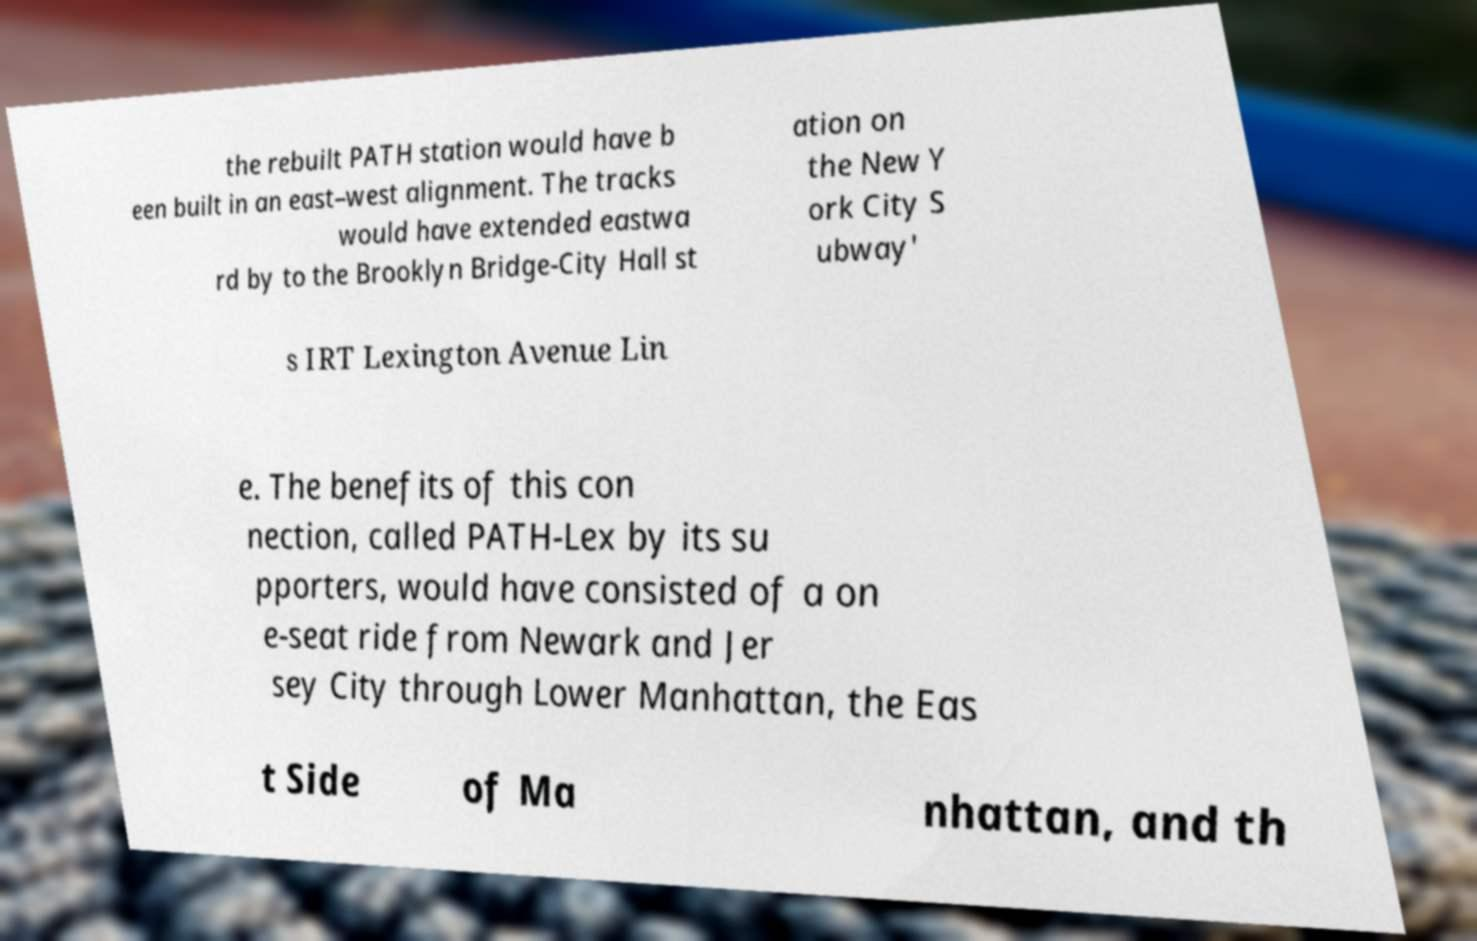Please identify and transcribe the text found in this image. the rebuilt PATH station would have b een built in an east–west alignment. The tracks would have extended eastwa rd by to the Brooklyn Bridge-City Hall st ation on the New Y ork City S ubway' s IRT Lexington Avenue Lin e. The benefits of this con nection, called PATH-Lex by its su pporters, would have consisted of a on e-seat ride from Newark and Jer sey City through Lower Manhattan, the Eas t Side of Ma nhattan, and th 